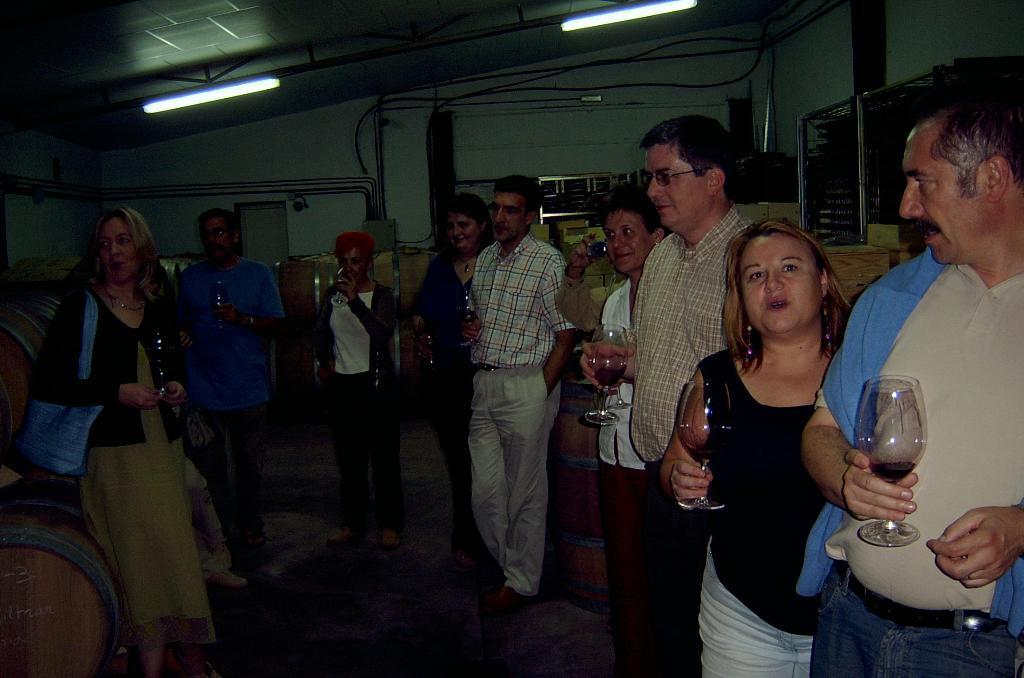How would you summarize this image in a sentence or two? In this image we can see a group of people standing on the floor holding the glasses. We can also see some drums on the backside. On the backside we can see a wall and some ceiling lights to a roof. 